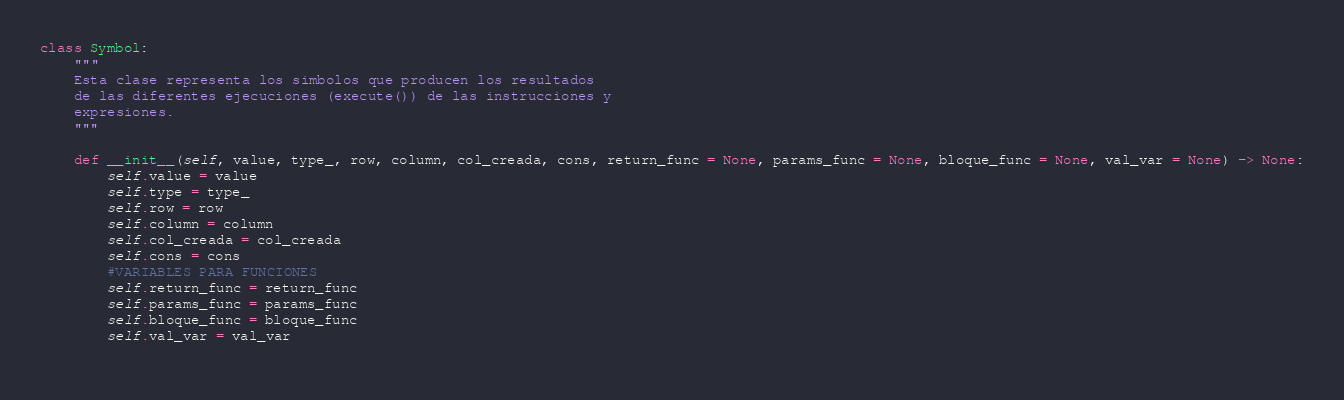<code> <loc_0><loc_0><loc_500><loc_500><_Python_>class Symbol:
    """
    Esta clase representa los simbolos que producen los resultados
    de las diferentes ejecuciones (execute()) de las instrucciones y
    expresiones.
    """

    def __init__(self, value, type_, row, column, col_creada, cons, return_func = None, params_func = None, bloque_func = None, val_var = None) -> None:
        self.value = value
        self.type = type_
        self.row = row
        self.column = column
        self.col_creada = col_creada
        self.cons = cons
        #VARIABLES PARA FUNCIONES
        self.return_func = return_func
        self.params_func = params_func
        self.bloque_func = bloque_func
        self.val_var = val_var
        

</code> 